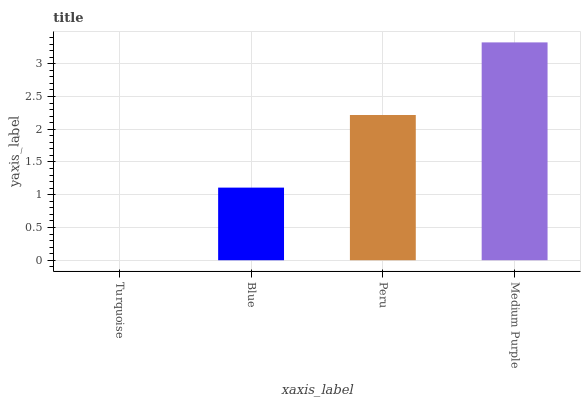Is Turquoise the minimum?
Answer yes or no. Yes. Is Medium Purple the maximum?
Answer yes or no. Yes. Is Blue the minimum?
Answer yes or no. No. Is Blue the maximum?
Answer yes or no. No. Is Blue greater than Turquoise?
Answer yes or no. Yes. Is Turquoise less than Blue?
Answer yes or no. Yes. Is Turquoise greater than Blue?
Answer yes or no. No. Is Blue less than Turquoise?
Answer yes or no. No. Is Peru the high median?
Answer yes or no. Yes. Is Blue the low median?
Answer yes or no. Yes. Is Blue the high median?
Answer yes or no. No. Is Peru the low median?
Answer yes or no. No. 